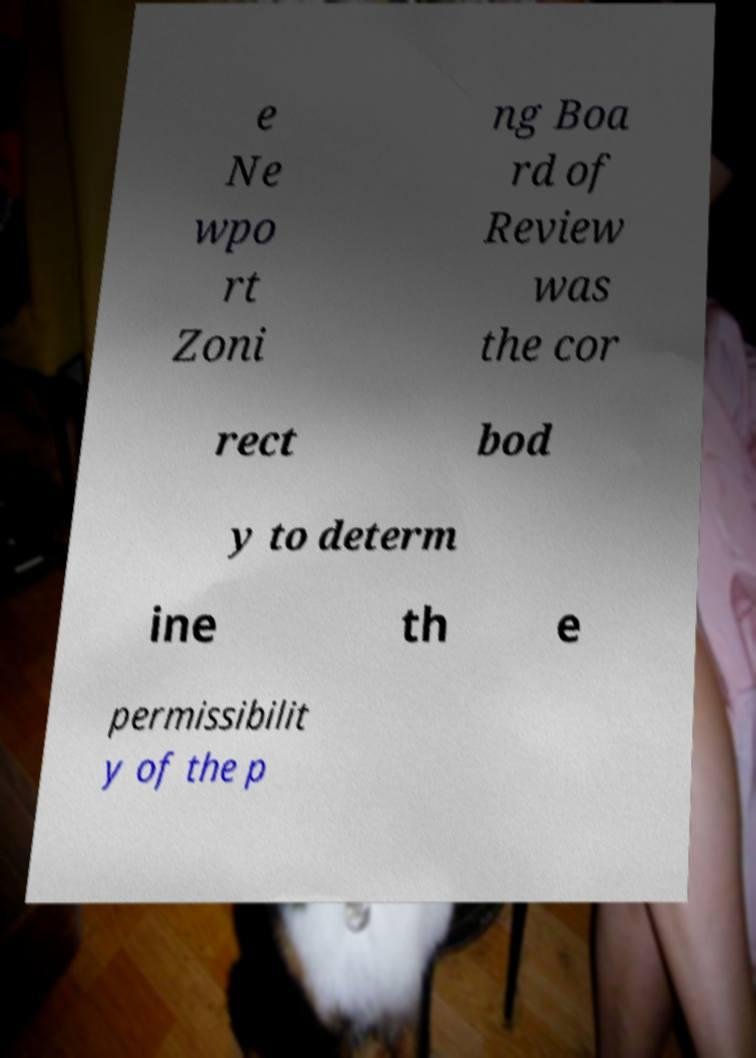There's text embedded in this image that I need extracted. Can you transcribe it verbatim? e Ne wpo rt Zoni ng Boa rd of Review was the cor rect bod y to determ ine th e permissibilit y of the p 